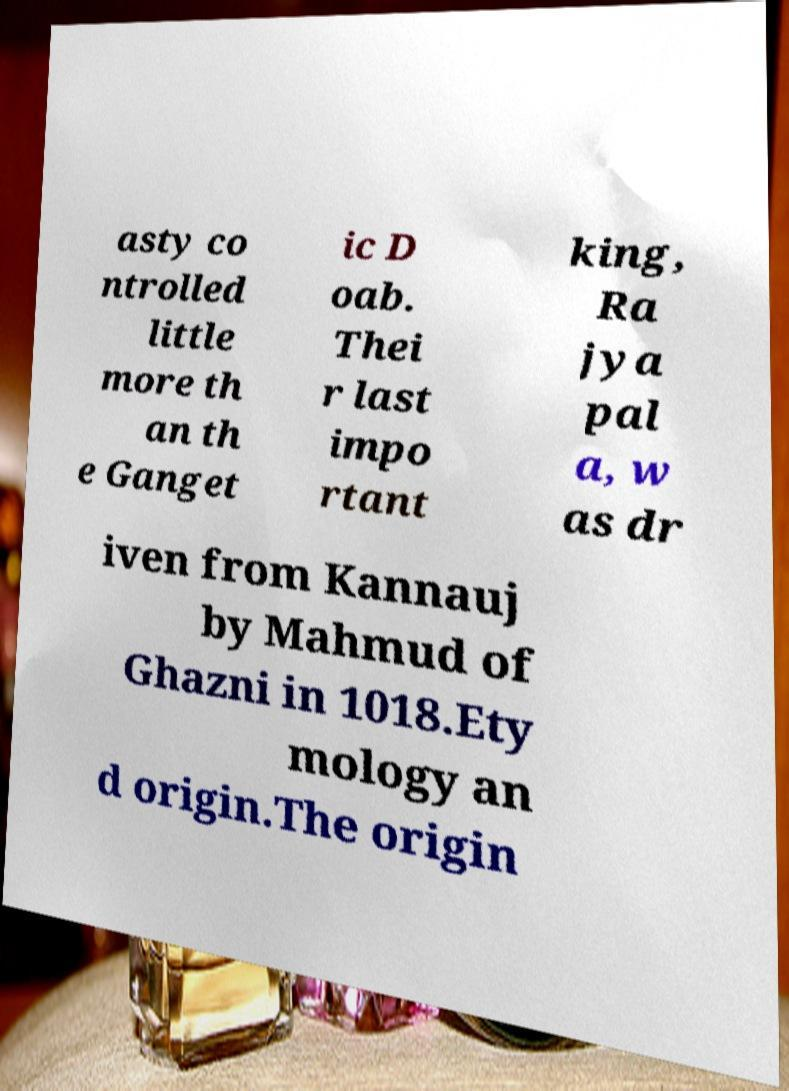What messages or text are displayed in this image? I need them in a readable, typed format. asty co ntrolled little more th an th e Ganget ic D oab. Thei r last impo rtant king, Ra jya pal a, w as dr iven from Kannauj by Mahmud of Ghazni in 1018.Ety mology an d origin.The origin 